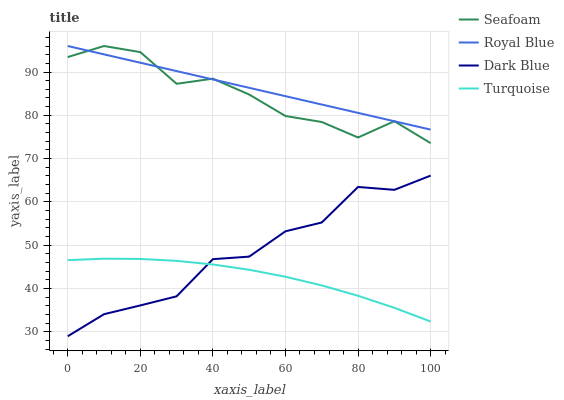Does Turquoise have the minimum area under the curve?
Answer yes or no. Yes. Does Royal Blue have the maximum area under the curve?
Answer yes or no. Yes. Does Seafoam have the minimum area under the curve?
Answer yes or no. No. Does Seafoam have the maximum area under the curve?
Answer yes or no. No. Is Royal Blue the smoothest?
Answer yes or no. Yes. Is Seafoam the roughest?
Answer yes or no. Yes. Is Turquoise the smoothest?
Answer yes or no. No. Is Turquoise the roughest?
Answer yes or no. No. Does Dark Blue have the lowest value?
Answer yes or no. Yes. Does Turquoise have the lowest value?
Answer yes or no. No. Does Seafoam have the highest value?
Answer yes or no. Yes. Does Turquoise have the highest value?
Answer yes or no. No. Is Dark Blue less than Seafoam?
Answer yes or no. Yes. Is Seafoam greater than Turquoise?
Answer yes or no. Yes. Does Dark Blue intersect Turquoise?
Answer yes or no. Yes. Is Dark Blue less than Turquoise?
Answer yes or no. No. Is Dark Blue greater than Turquoise?
Answer yes or no. No. Does Dark Blue intersect Seafoam?
Answer yes or no. No. 